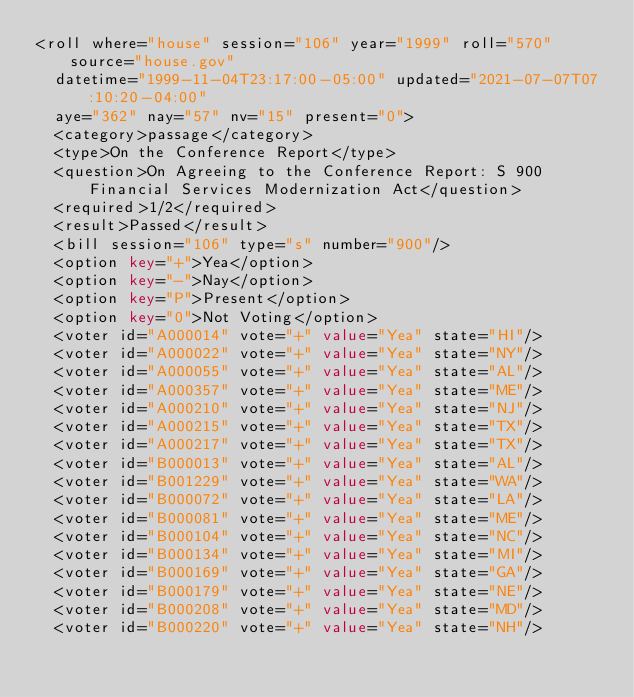Convert code to text. <code><loc_0><loc_0><loc_500><loc_500><_XML_><roll where="house" session="106" year="1999" roll="570" source="house.gov"
  datetime="1999-11-04T23:17:00-05:00" updated="2021-07-07T07:10:20-04:00"
  aye="362" nay="57" nv="15" present="0">
  <category>passage</category>
  <type>On the Conference Report</type>
  <question>On Agreeing to the Conference Report: S 900 Financial Services Modernization Act</question>
  <required>1/2</required>
  <result>Passed</result>
  <bill session="106" type="s" number="900"/>
  <option key="+">Yea</option>
  <option key="-">Nay</option>
  <option key="P">Present</option>
  <option key="0">Not Voting</option>
  <voter id="A000014" vote="+" value="Yea" state="HI"/>
  <voter id="A000022" vote="+" value="Yea" state="NY"/>
  <voter id="A000055" vote="+" value="Yea" state="AL"/>
  <voter id="A000357" vote="+" value="Yea" state="ME"/>
  <voter id="A000210" vote="+" value="Yea" state="NJ"/>
  <voter id="A000215" vote="+" value="Yea" state="TX"/>
  <voter id="A000217" vote="+" value="Yea" state="TX"/>
  <voter id="B000013" vote="+" value="Yea" state="AL"/>
  <voter id="B001229" vote="+" value="Yea" state="WA"/>
  <voter id="B000072" vote="+" value="Yea" state="LA"/>
  <voter id="B000081" vote="+" value="Yea" state="ME"/>
  <voter id="B000104" vote="+" value="Yea" state="NC"/>
  <voter id="B000134" vote="+" value="Yea" state="MI"/>
  <voter id="B000169" vote="+" value="Yea" state="GA"/>
  <voter id="B000179" vote="+" value="Yea" state="NE"/>
  <voter id="B000208" vote="+" value="Yea" state="MD"/>
  <voter id="B000220" vote="+" value="Yea" state="NH"/></code> 